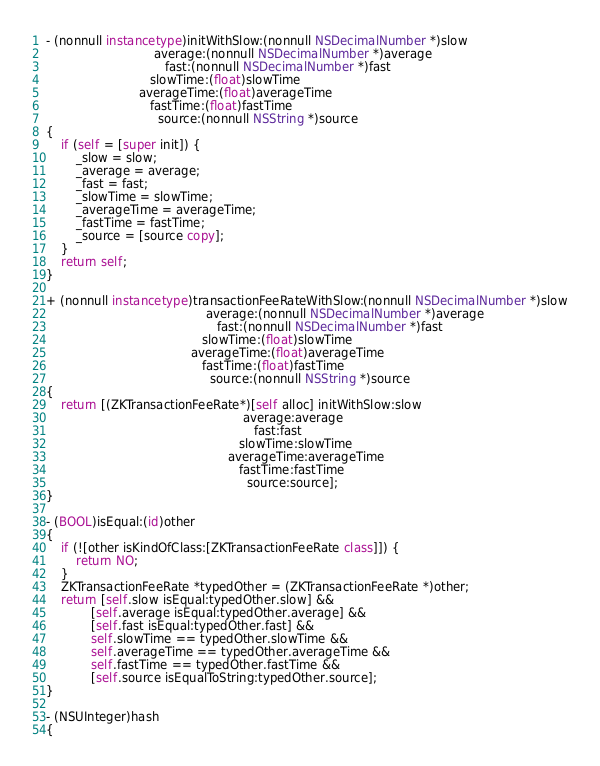<code> <loc_0><loc_0><loc_500><loc_500><_ObjectiveC_>
- (nonnull instancetype)initWithSlow:(nonnull NSDecimalNumber *)slow
                             average:(nonnull NSDecimalNumber *)average
                                fast:(nonnull NSDecimalNumber *)fast
                            slowTime:(float)slowTime
                         averageTime:(float)averageTime
                            fastTime:(float)fastTime
                              source:(nonnull NSString *)source
{
    if (self = [super init]) {
        _slow = slow;
        _average = average;
        _fast = fast;
        _slowTime = slowTime;
        _averageTime = averageTime;
        _fastTime = fastTime;
        _source = [source copy];
    }
    return self;
}

+ (nonnull instancetype)transactionFeeRateWithSlow:(nonnull NSDecimalNumber *)slow
                                           average:(nonnull NSDecimalNumber *)average
                                              fast:(nonnull NSDecimalNumber *)fast
                                          slowTime:(float)slowTime
                                       averageTime:(float)averageTime
                                          fastTime:(float)fastTime
                                            source:(nonnull NSString *)source
{
    return [(ZKTransactionFeeRate*)[self alloc] initWithSlow:slow
                                                     average:average
                                                        fast:fast
                                                    slowTime:slowTime
                                                 averageTime:averageTime
                                                    fastTime:fastTime
                                                      source:source];
}

- (BOOL)isEqual:(id)other
{
    if (![other isKindOfClass:[ZKTransactionFeeRate class]]) {
        return NO;
    }
    ZKTransactionFeeRate *typedOther = (ZKTransactionFeeRate *)other;
    return [self.slow isEqual:typedOther.slow] &&
            [self.average isEqual:typedOther.average] &&
            [self.fast isEqual:typedOther.fast] &&
            self.slowTime == typedOther.slowTime &&
            self.averageTime == typedOther.averageTime &&
            self.fastTime == typedOther.fastTime &&
            [self.source isEqualToString:typedOther.source];
}

- (NSUInteger)hash
{</code> 